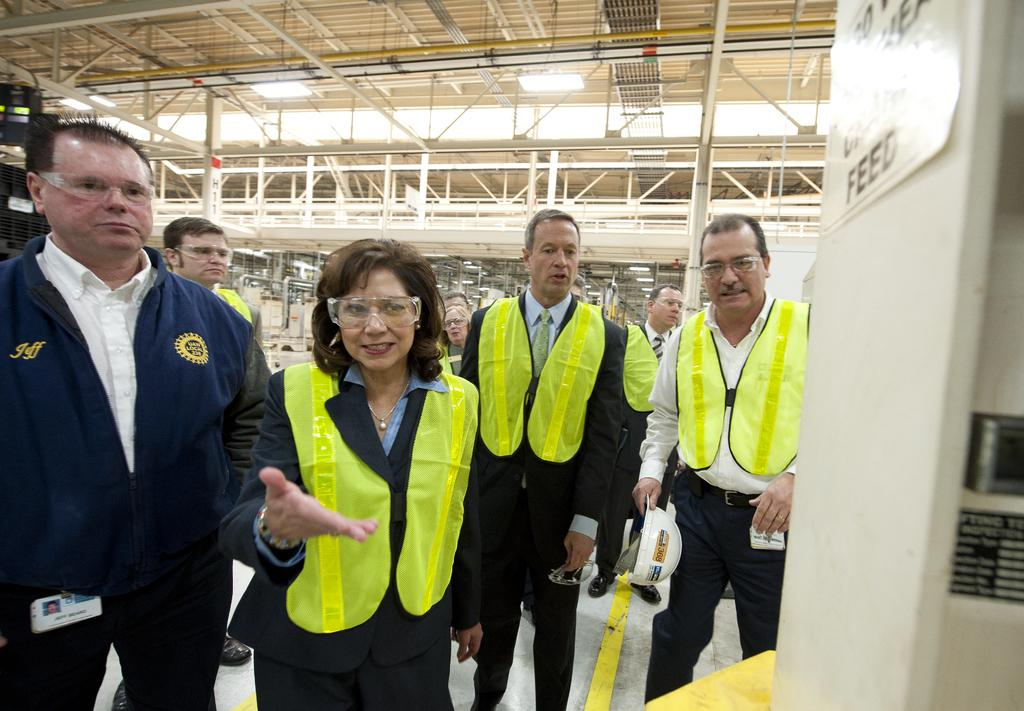What is happening in the image involving a group of people? There is a group of people standing in the image. What can be seen in the image that might be used for identification purposes? There are name boards in the image. What is the lighting situation in the image? There is a ceiling with lights in the image. What type of structure is present in the image? There are iron frames in the image. What else can be seen in the image that might provide support or stability? There are poles in the image. Can you describe any other objects present in the image? There are other objects in the image, but their specific details are not mentioned in the provided facts. Where is the cave located in the image? There is no cave present in the image. Can you describe the frog sitting on the mountain in the image? There is no frog or mountain present in the image. 